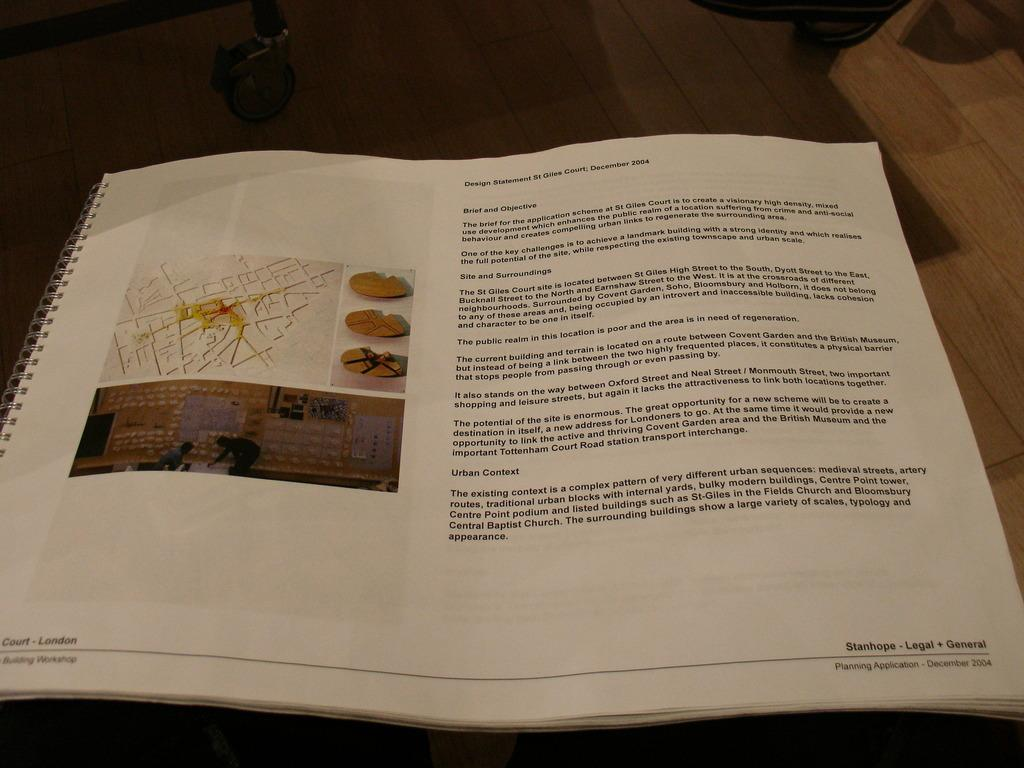<image>
Write a terse but informative summary of the picture. A spiral-bound book shows a planning application from December of 2004. 